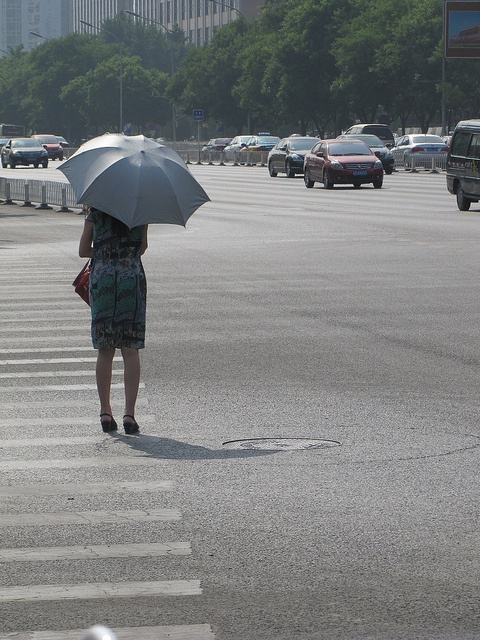Describe the objects in this image and their specific colors. I can see umbrella in gray, darkgray, and lightgray tones, people in gray and black tones, car in gray, black, and darkgray tones, car in gray, black, darkgray, and purple tones, and car in gray, darkgray, and lightgray tones in this image. 